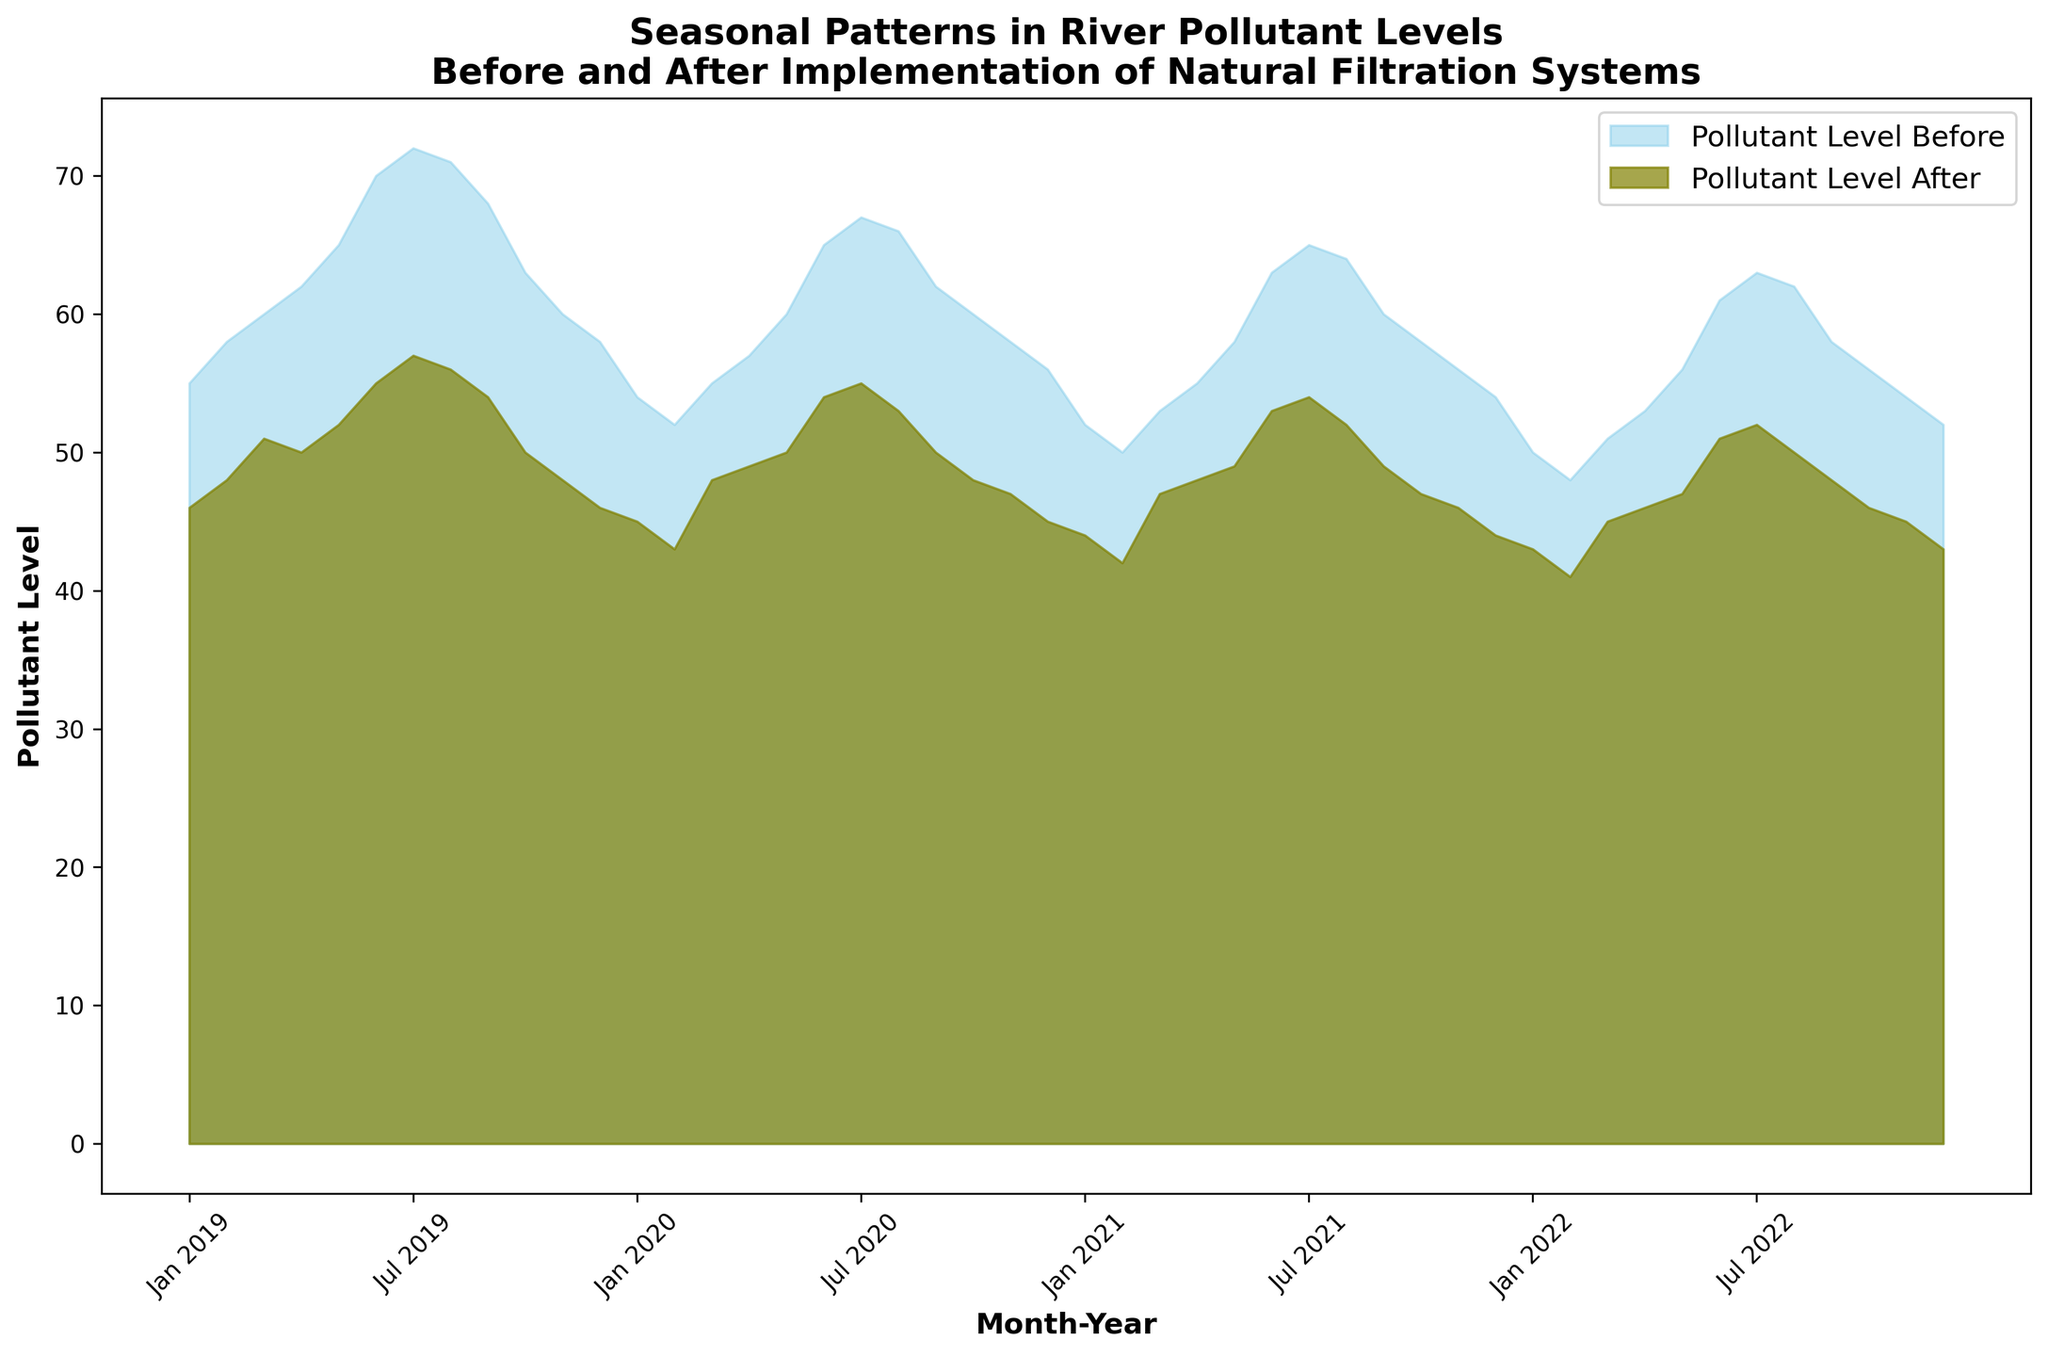What seasonal trend in pollutant levels can be observed from January to December for the year 2019 before the implementation of natural filtration systems? The pollutant levels before the implementation start at 55 in January, increasing steadily to a peak of 72 in July, and then decreasing to 58 by December. This shows a trend of increasing pollutant levels through spring and summer, with a peak in mid-summer, followed by a decline in fall and winter.
Answer: An increasing trend through spring and summer, peaking mid-summer, then declining How did the implementation of natural filtration systems affect pollutant levels in August 2019? In August 2019, the pollutant level before implementation was 71, while after implementation it was reduced to 56. The pollutant levels decreased following the implementation.
Answer: Reduced from 71 to 56 During which month and year was the highest decrease in pollutant levels observed after implementation? The highest decrease can be calculated by finding the difference between 'Pollutant_Level_Before' and 'Pollutant_Level_After'. The largest difference observed is between July 2019 with a reduction from 72 to 57, resulting in a decrease of 15 units.
Answer: July 2019 Comparing January in each year, how did pollutant levels change before and after the implementation? For January of each year:
- 2019: Before 55, After 46
- 2020: Before 54, After 45
- 2021: Before 52, After 44
- 2022: Before 50, After 43
In all these years, the pollutant levels decreased consistently after the implementation. The decrease ranges from 7-9 units.
Answer: Consistent decrease, ranging from 7-9 units Which year had the most significant overall decline in pollutant levels from January to December before implementation? By examining the pollutant levels before implementation throughout each year, 2019 has the highest pollutant level in January starting at 55 and ending at 58 in December, while 2022 had the lowest start at 50 and end at 52. This shows that 2019 starts with higher levels and has more room for change.
Answer: 2019 By June 2022, what is the difference in pollutant levels before and after implementation, and what does this indicate? In June 2022, the levels before implementation are 61 and after are 51. The difference is 10 units. This indicates a significant reduction in pollutant levels after the implementation of natural filtration systems.
Answer: Reduced by 10 units During which months do we observe a consistent maximum decrease in pollutant levels every year after the implementation of natural filtration systems? Looking through the data month by month for each year, the most consistent maximum decrease in pollutant levels typically occurs in the summer months (July and August). Each year during these months, there is a significant decrease observed.
Answer: Summer months (July and August) What is the average pollutant level after implementation across all years for the month of December? Average pollutant level for December after implementation across 2019, 2020, 2021, and 2022 is calculated as (46 + 45 + 44 + 43) / 4. This results in an average of 44.5.
Answer: 44.5 